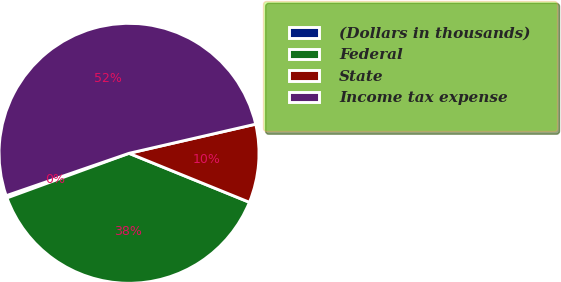Convert chart to OTSL. <chart><loc_0><loc_0><loc_500><loc_500><pie_chart><fcel>(Dollars in thousands)<fcel>Federal<fcel>State<fcel>Income tax expense<nl><fcel>0.29%<fcel>38.27%<fcel>9.75%<fcel>51.68%<nl></chart> 